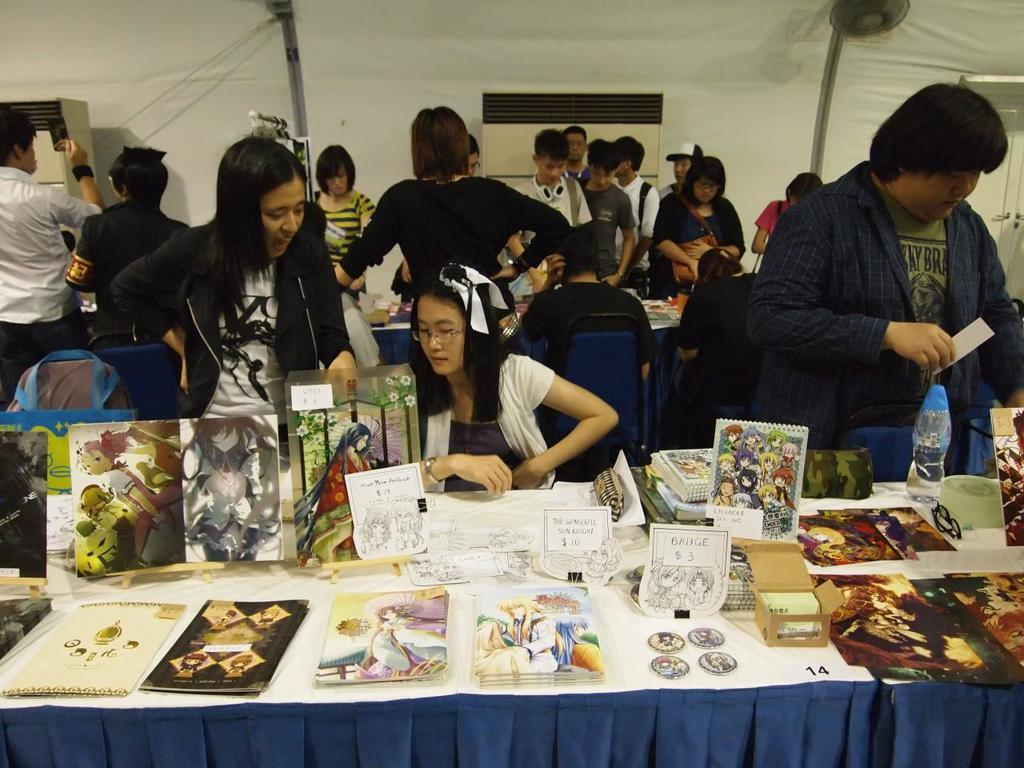What are the people in the image doing? The people in the image are standing and sitting. Can you describe the seating arrangement in the image? There is a person sitting in the image. What is present in the image besides the people? There is a table in the image. What can be found on the table? There are objects placed on the table. What type of stone can be seen on the table in the image? There is no stone present on the table in the image. How many sisters are visible in the image? The provided facts do not mention any sisters, so we cannot determine the number of sisters in the image. 